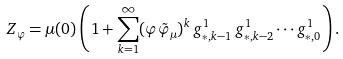Convert formula to latex. <formula><loc_0><loc_0><loc_500><loc_500>Z _ { \varphi } = \mu ( 0 ) \left ( 1 + \sum _ { k = 1 } ^ { \infty } ( \varphi \tilde { \varphi } _ { \mu } ) ^ { k } \, g _ { * , k - 1 } ^ { 1 } \, g _ { * , k - 2 } ^ { 1 } \cdots g _ { * , 0 } ^ { 1 } \right ) .</formula> 